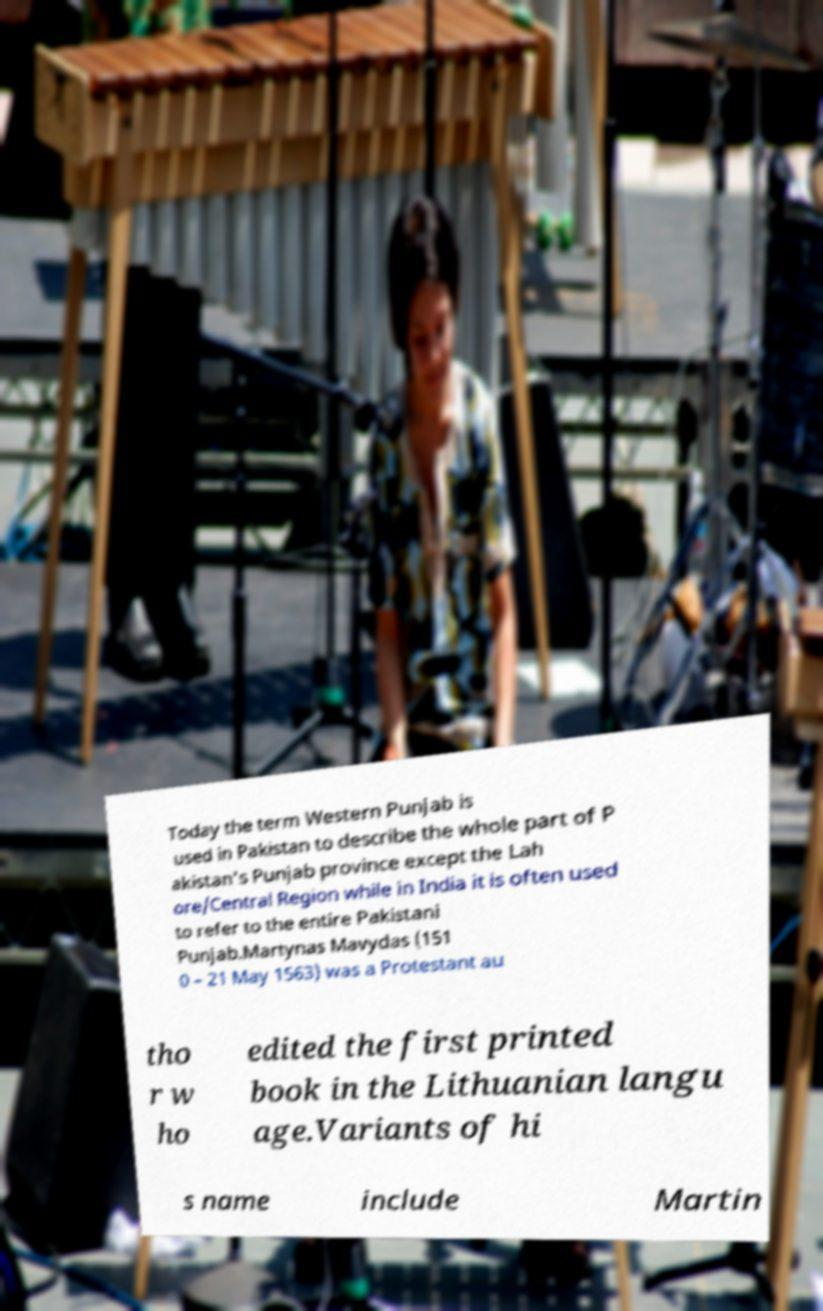Can you accurately transcribe the text from the provided image for me? Today the term Western Punjab is used in Pakistan to describe the whole part of P akistan's Punjab province except the Lah ore/Central Region while in India it is often used to refer to the entire Pakistani Punjab.Martynas Mavydas (151 0 – 21 May 1563) was a Protestant au tho r w ho edited the first printed book in the Lithuanian langu age.Variants of hi s name include Martin 